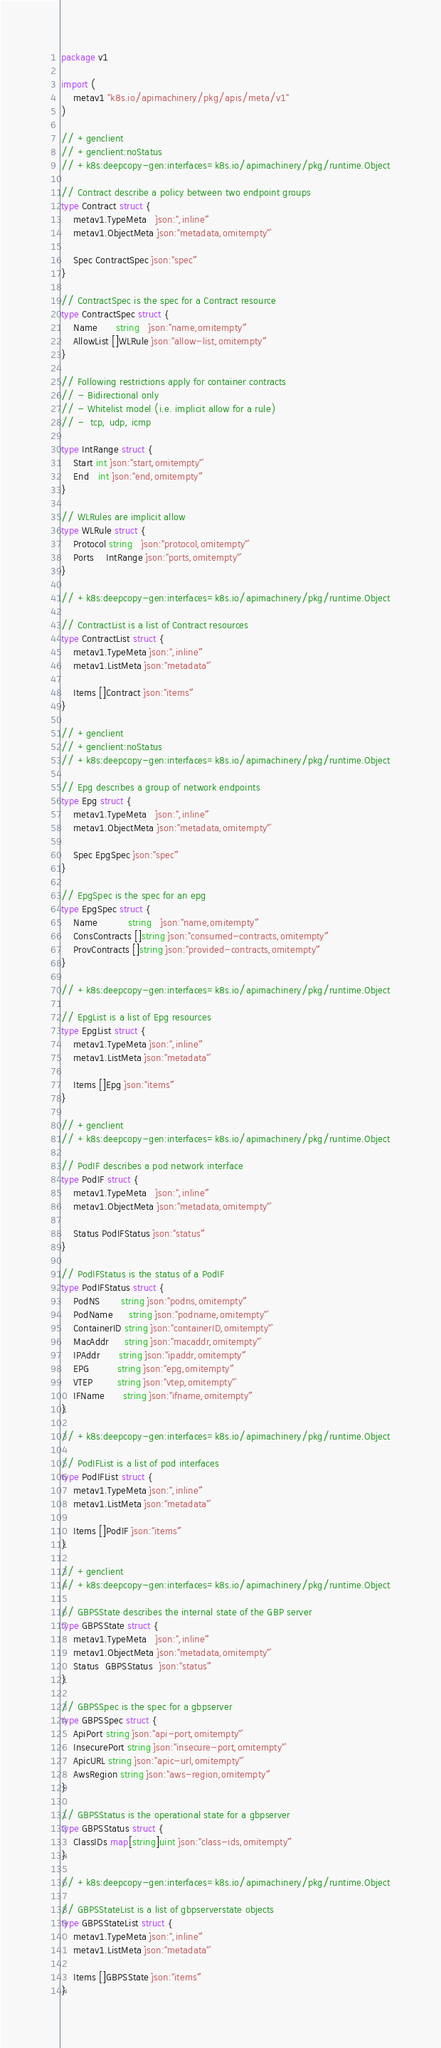<code> <loc_0><loc_0><loc_500><loc_500><_Go_>package v1

import (
	metav1 "k8s.io/apimachinery/pkg/apis/meta/v1"
)

// +genclient
// +genclient:noStatus
// +k8s:deepcopy-gen:interfaces=k8s.io/apimachinery/pkg/runtime.Object

// Contract describe a policy between two endpoint groups
type Contract struct {
	metav1.TypeMeta   `json:",inline"`
	metav1.ObjectMeta `json:"metadata,omitempty"`

	Spec ContractSpec `json:"spec"`
}

// ContractSpec is the spec for a Contract resource
type ContractSpec struct {
	Name      string   `json:"name,omitempty"`
	AllowList []WLRule `json:"allow-list,omitempty"`
}

// Following restrictions apply for container contracts
// - Bidirectional only
// - Whitelist model (i.e. implicit allow for a rule)
// -  tcp, udp, icmp

type IntRange struct {
	Start int `json:"start,omitempty"`
	End   int `json:"end,omitempty"`
}

// WLRules are implicit allow
type WLRule struct {
	Protocol string   `json:"protocol,omitempty"`
	Ports    IntRange `json:"ports,omitempty"`
}

// +k8s:deepcopy-gen:interfaces=k8s.io/apimachinery/pkg/runtime.Object

// ContractList is a list of Contract resources
type ContractList struct {
	metav1.TypeMeta `json:",inline"`
	metav1.ListMeta `json:"metadata"`

	Items []Contract `json:"items"`
}

// +genclient
// +genclient:noStatus
// +k8s:deepcopy-gen:interfaces=k8s.io/apimachinery/pkg/runtime.Object

// Epg describes a group of network endpoints
type Epg struct {
	metav1.TypeMeta   `json:",inline"`
	metav1.ObjectMeta `json:"metadata,omitempty"`

	Spec EpgSpec `json:"spec"`
}

// EpgSpec is the spec for an epg
type EpgSpec struct {
	Name          string   `json:"name,omitempty"`
	ConsContracts []string `json:"consumed-contracts,omitempty"`
	ProvContracts []string `json:"provided-contracts,omitempty"`
}

// +k8s:deepcopy-gen:interfaces=k8s.io/apimachinery/pkg/runtime.Object

// EpgList is a list of Epg resources
type EpgList struct {
	metav1.TypeMeta `json:",inline"`
	metav1.ListMeta `json:"metadata"`

	Items []Epg `json:"items"`
}

// +genclient
// +k8s:deepcopy-gen:interfaces=k8s.io/apimachinery/pkg/runtime.Object

// PodIF describes a pod network interface
type PodIF struct {
	metav1.TypeMeta   `json:",inline"`
	metav1.ObjectMeta `json:"metadata,omitempty"`

	Status PodIFStatus `json:"status"`
}

// PodIFStatus is the status of a PodIF
type PodIFStatus struct {
	PodNS       string `json:"podns,omitempty"`
	PodName     string `json:"podname,omitempty"`
	ContainerID string `json:"containerID,omitempty"`
	MacAddr     string `json:"macaddr,omitempty"`
	IPAddr      string `json:"ipaddr,omitempty"`
	EPG         string `json:"epg,omitempty"`
	VTEP        string `json:"vtep,omitempty"`
	IFName      string `json:"ifname,omitempty"`
}

// +k8s:deepcopy-gen:interfaces=k8s.io/apimachinery/pkg/runtime.Object

// PodIFList is a list of pod interfaces
type PodIFList struct {
	metav1.TypeMeta `json:",inline"`
	metav1.ListMeta `json:"metadata"`

	Items []PodIF `json:"items"`
}

// +genclient
// +k8s:deepcopy-gen:interfaces=k8s.io/apimachinery/pkg/runtime.Object

// GBPSState describes the internal state of the GBP server
type GBPSState struct {
	metav1.TypeMeta   `json:",inline"`
	metav1.ObjectMeta `json:"metadata,omitempty"`
	Status  GBPSStatus  `json:"status"`
}

// GBPSSpec is the spec for a gbpserver
type GBPSSpec struct {
	ApiPort string `json:"api-port,omitempty"`
	InsecurePort string `json:"insecure-port,omitempty"`
	ApicURL string `json:"apic-url,omitempty"`
	AwsRegion string `json:"aws-region,omitempty"`
}

// GBPSStatus is the operational state for a gbpserver
type GBPSStatus struct {
	ClassIDs map[string]uint `json:"class-ids,omitempty"`
}

// +k8s:deepcopy-gen:interfaces=k8s.io/apimachinery/pkg/runtime.Object

// GBPSStateList is a list of gbpserverstate objects
type GBPSStateList struct {
	metav1.TypeMeta `json:",inline"`
	metav1.ListMeta `json:"metadata"`

	Items []GBPSState `json:"items"`
}
</code> 